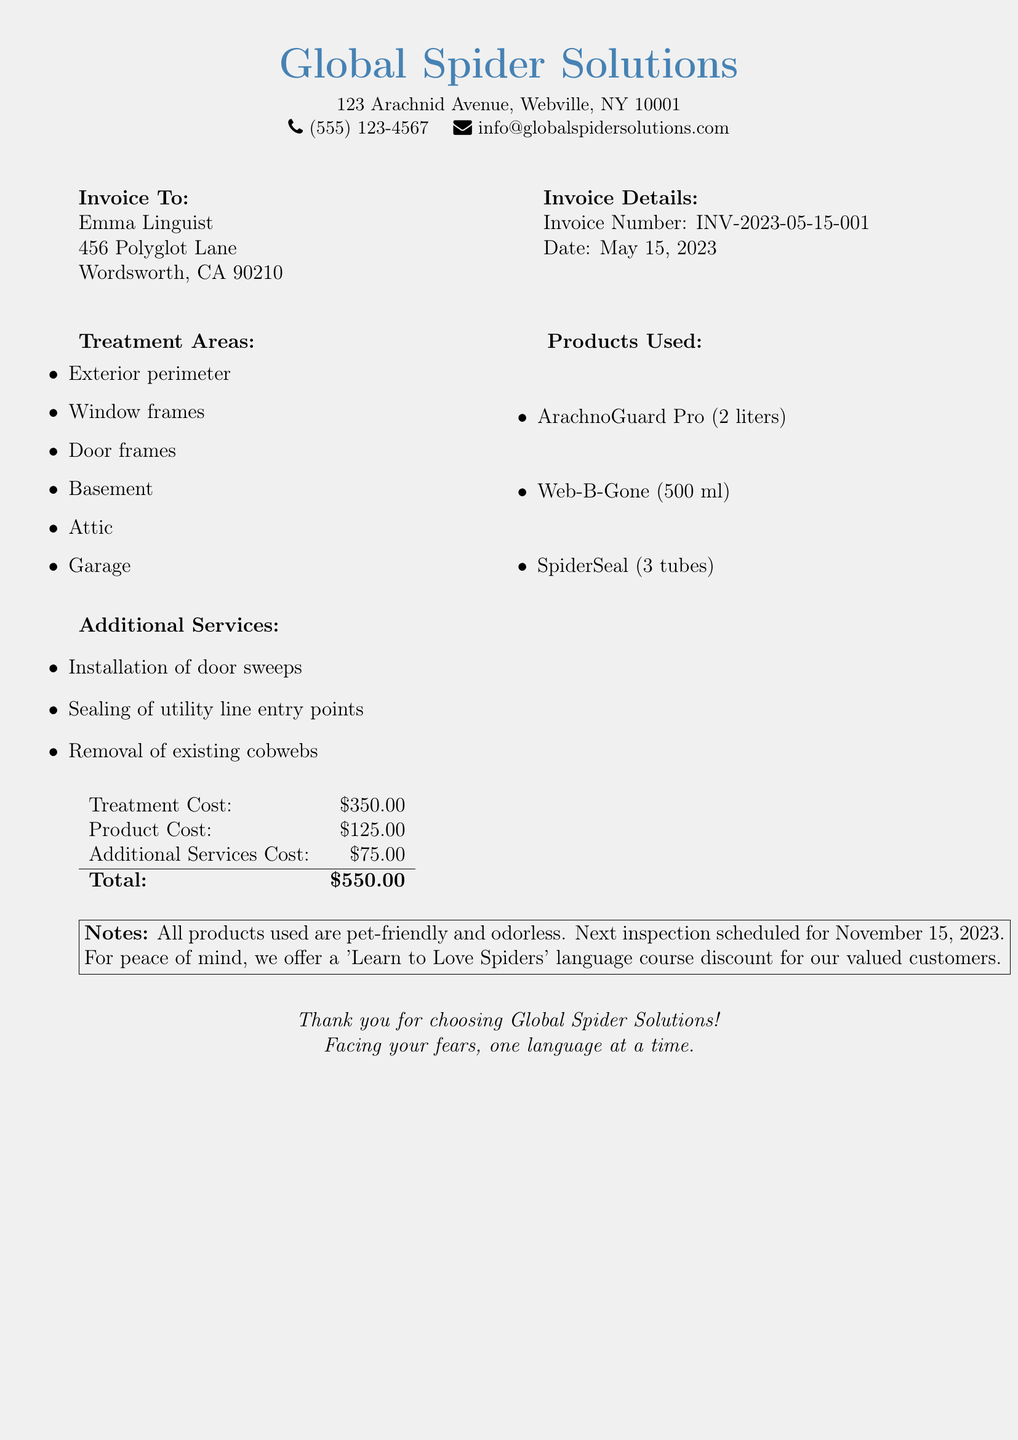What is the invoice number? The invoice number is listed under the invoice details section.
Answer: INV-2023-05-15-001 What is the total cost of the treatment? The total cost is calculated from the treatment cost, product cost, and additional services cost.
Answer: $550.00 Which product was used in the largest quantity? The products used are listed, and the quantity of each is provided.
Answer: ArachnoGuard Pro How many areas were treated? The treatment areas are listed in a bullet format, providing a count of the areas.
Answer: 6 What additional service was provided? The additional services are listed in bullet points, describing each one.
Answer: Installation of door sweeps When is the next inspection scheduled? The next inspection date is mentioned in the notes section of the document.
Answer: November 15, 2023 What is the address of the pest control company? The address is located at the top of the document under the company name.
Answer: 123 Arachnid Avenue, Webville, NY 10001 What is the treatment cost? The treatment cost is found in the breakdown of costs at the bottom of the document.
Answer: $350.00 What is the reason for the 'Learn to Love Spiders' course discount? The note at the bottom implies a benefit for valued customers.
Answer: Peace of mind 